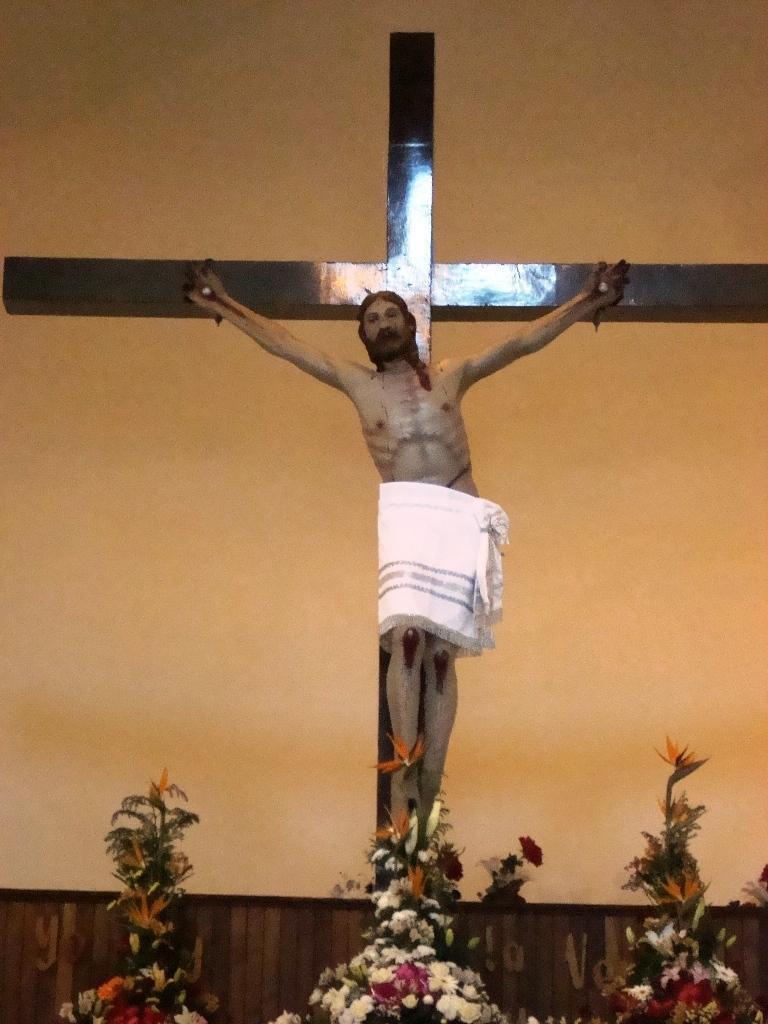Could you give a brief overview of what you see in this image? In this image I see a sculpture of a man on this sign and I see flowers over here which are colorful and I see the wall which is of orange in color. 